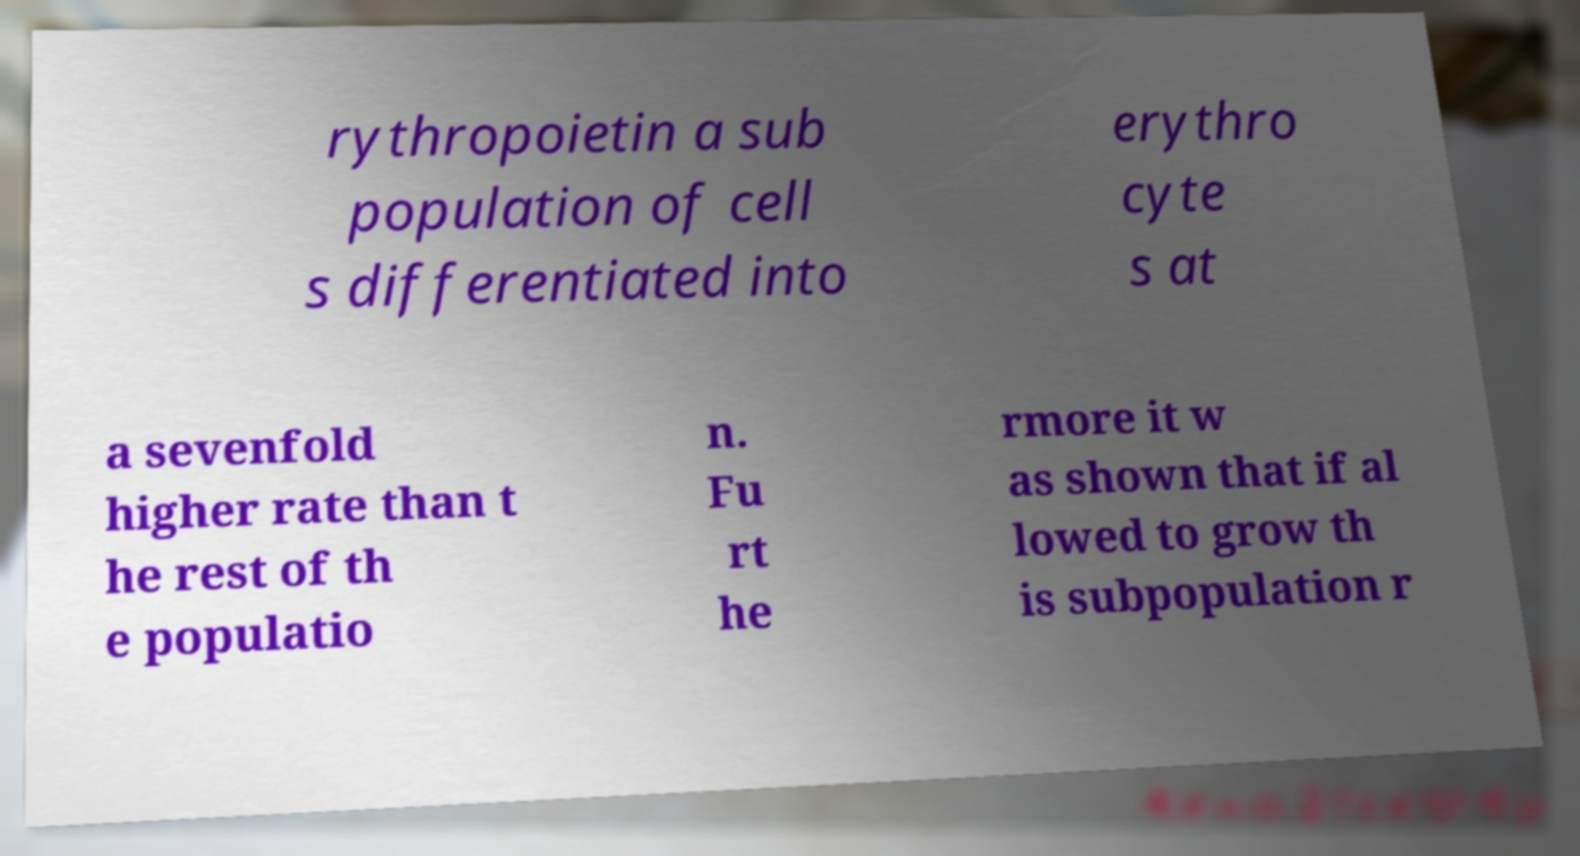I need the written content from this picture converted into text. Can you do that? rythropoietin a sub population of cell s differentiated into erythro cyte s at a sevenfold higher rate than t he rest of th e populatio n. Fu rt he rmore it w as shown that if al lowed to grow th is subpopulation r 